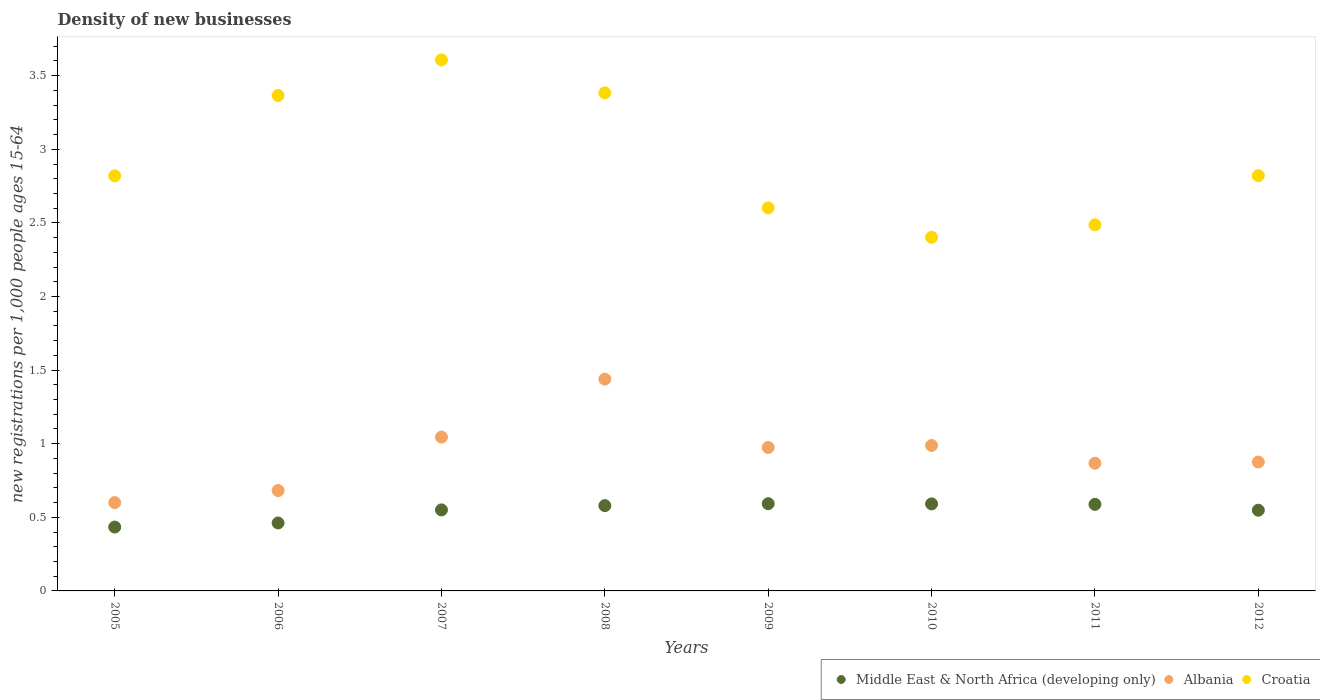What is the number of new registrations in Albania in 2011?
Your response must be concise. 0.87. Across all years, what is the maximum number of new registrations in Middle East & North Africa (developing only)?
Keep it short and to the point. 0.59. Across all years, what is the minimum number of new registrations in Croatia?
Offer a terse response. 2.4. In which year was the number of new registrations in Croatia maximum?
Ensure brevity in your answer.  2007. In which year was the number of new registrations in Croatia minimum?
Offer a terse response. 2010. What is the total number of new registrations in Albania in the graph?
Your response must be concise. 7.47. What is the difference between the number of new registrations in Albania in 2006 and that in 2010?
Provide a succinct answer. -0.31. What is the difference between the number of new registrations in Albania in 2007 and the number of new registrations in Croatia in 2009?
Make the answer very short. -1.56. What is the average number of new registrations in Middle East & North Africa (developing only) per year?
Ensure brevity in your answer.  0.54. In the year 2005, what is the difference between the number of new registrations in Albania and number of new registrations in Croatia?
Make the answer very short. -2.22. What is the ratio of the number of new registrations in Albania in 2008 to that in 2011?
Your answer should be very brief. 1.66. Is the number of new registrations in Croatia in 2009 less than that in 2011?
Ensure brevity in your answer.  No. Is the difference between the number of new registrations in Albania in 2005 and 2012 greater than the difference between the number of new registrations in Croatia in 2005 and 2012?
Keep it short and to the point. No. What is the difference between the highest and the second highest number of new registrations in Albania?
Keep it short and to the point. 0.39. What is the difference between the highest and the lowest number of new registrations in Albania?
Keep it short and to the point. 0.84. In how many years, is the number of new registrations in Albania greater than the average number of new registrations in Albania taken over all years?
Provide a short and direct response. 4. Is the sum of the number of new registrations in Middle East & North Africa (developing only) in 2005 and 2010 greater than the maximum number of new registrations in Albania across all years?
Offer a terse response. No. Does the number of new registrations in Middle East & North Africa (developing only) monotonically increase over the years?
Give a very brief answer. No. Is the number of new registrations in Middle East & North Africa (developing only) strictly greater than the number of new registrations in Albania over the years?
Your answer should be very brief. No. Is the number of new registrations in Croatia strictly less than the number of new registrations in Middle East & North Africa (developing only) over the years?
Keep it short and to the point. No. What is the difference between two consecutive major ticks on the Y-axis?
Your answer should be very brief. 0.5. Does the graph contain grids?
Provide a succinct answer. No. Where does the legend appear in the graph?
Your response must be concise. Bottom right. How many legend labels are there?
Your answer should be compact. 3. What is the title of the graph?
Your answer should be compact. Density of new businesses. What is the label or title of the X-axis?
Ensure brevity in your answer.  Years. What is the label or title of the Y-axis?
Your response must be concise. New registrations per 1,0 people ages 15-64. What is the new registrations per 1,000 people ages 15-64 in Middle East & North Africa (developing only) in 2005?
Provide a short and direct response. 0.43. What is the new registrations per 1,000 people ages 15-64 of Albania in 2005?
Make the answer very short. 0.6. What is the new registrations per 1,000 people ages 15-64 in Croatia in 2005?
Your response must be concise. 2.82. What is the new registrations per 1,000 people ages 15-64 in Middle East & North Africa (developing only) in 2006?
Your response must be concise. 0.46. What is the new registrations per 1,000 people ages 15-64 in Albania in 2006?
Provide a short and direct response. 0.68. What is the new registrations per 1,000 people ages 15-64 of Croatia in 2006?
Make the answer very short. 3.37. What is the new registrations per 1,000 people ages 15-64 of Middle East & North Africa (developing only) in 2007?
Provide a short and direct response. 0.55. What is the new registrations per 1,000 people ages 15-64 of Albania in 2007?
Your response must be concise. 1.04. What is the new registrations per 1,000 people ages 15-64 of Croatia in 2007?
Offer a very short reply. 3.61. What is the new registrations per 1,000 people ages 15-64 of Middle East & North Africa (developing only) in 2008?
Ensure brevity in your answer.  0.58. What is the new registrations per 1,000 people ages 15-64 of Albania in 2008?
Provide a short and direct response. 1.44. What is the new registrations per 1,000 people ages 15-64 in Croatia in 2008?
Offer a terse response. 3.38. What is the new registrations per 1,000 people ages 15-64 of Middle East & North Africa (developing only) in 2009?
Make the answer very short. 0.59. What is the new registrations per 1,000 people ages 15-64 in Albania in 2009?
Provide a short and direct response. 0.97. What is the new registrations per 1,000 people ages 15-64 in Croatia in 2009?
Make the answer very short. 2.6. What is the new registrations per 1,000 people ages 15-64 in Middle East & North Africa (developing only) in 2010?
Give a very brief answer. 0.59. What is the new registrations per 1,000 people ages 15-64 in Albania in 2010?
Your response must be concise. 0.99. What is the new registrations per 1,000 people ages 15-64 in Croatia in 2010?
Offer a very short reply. 2.4. What is the new registrations per 1,000 people ages 15-64 in Middle East & North Africa (developing only) in 2011?
Ensure brevity in your answer.  0.59. What is the new registrations per 1,000 people ages 15-64 in Albania in 2011?
Your answer should be very brief. 0.87. What is the new registrations per 1,000 people ages 15-64 of Croatia in 2011?
Provide a short and direct response. 2.49. What is the new registrations per 1,000 people ages 15-64 in Middle East & North Africa (developing only) in 2012?
Keep it short and to the point. 0.55. What is the new registrations per 1,000 people ages 15-64 in Albania in 2012?
Give a very brief answer. 0.88. What is the new registrations per 1,000 people ages 15-64 of Croatia in 2012?
Offer a terse response. 2.82. Across all years, what is the maximum new registrations per 1,000 people ages 15-64 of Middle East & North Africa (developing only)?
Your answer should be very brief. 0.59. Across all years, what is the maximum new registrations per 1,000 people ages 15-64 in Albania?
Ensure brevity in your answer.  1.44. Across all years, what is the maximum new registrations per 1,000 people ages 15-64 of Croatia?
Provide a succinct answer. 3.61. Across all years, what is the minimum new registrations per 1,000 people ages 15-64 in Middle East & North Africa (developing only)?
Offer a very short reply. 0.43. Across all years, what is the minimum new registrations per 1,000 people ages 15-64 in Albania?
Offer a terse response. 0.6. Across all years, what is the minimum new registrations per 1,000 people ages 15-64 of Croatia?
Your answer should be very brief. 2.4. What is the total new registrations per 1,000 people ages 15-64 of Middle East & North Africa (developing only) in the graph?
Offer a terse response. 4.35. What is the total new registrations per 1,000 people ages 15-64 of Albania in the graph?
Your answer should be compact. 7.47. What is the total new registrations per 1,000 people ages 15-64 of Croatia in the graph?
Your answer should be very brief. 23.49. What is the difference between the new registrations per 1,000 people ages 15-64 of Middle East & North Africa (developing only) in 2005 and that in 2006?
Provide a succinct answer. -0.03. What is the difference between the new registrations per 1,000 people ages 15-64 in Albania in 2005 and that in 2006?
Give a very brief answer. -0.08. What is the difference between the new registrations per 1,000 people ages 15-64 in Croatia in 2005 and that in 2006?
Give a very brief answer. -0.55. What is the difference between the new registrations per 1,000 people ages 15-64 in Middle East & North Africa (developing only) in 2005 and that in 2007?
Ensure brevity in your answer.  -0.12. What is the difference between the new registrations per 1,000 people ages 15-64 of Albania in 2005 and that in 2007?
Give a very brief answer. -0.45. What is the difference between the new registrations per 1,000 people ages 15-64 in Croatia in 2005 and that in 2007?
Provide a succinct answer. -0.79. What is the difference between the new registrations per 1,000 people ages 15-64 in Middle East & North Africa (developing only) in 2005 and that in 2008?
Give a very brief answer. -0.15. What is the difference between the new registrations per 1,000 people ages 15-64 in Albania in 2005 and that in 2008?
Your response must be concise. -0.84. What is the difference between the new registrations per 1,000 people ages 15-64 of Croatia in 2005 and that in 2008?
Your answer should be compact. -0.56. What is the difference between the new registrations per 1,000 people ages 15-64 in Middle East & North Africa (developing only) in 2005 and that in 2009?
Offer a terse response. -0.16. What is the difference between the new registrations per 1,000 people ages 15-64 in Albania in 2005 and that in 2009?
Keep it short and to the point. -0.37. What is the difference between the new registrations per 1,000 people ages 15-64 in Croatia in 2005 and that in 2009?
Your answer should be very brief. 0.22. What is the difference between the new registrations per 1,000 people ages 15-64 of Middle East & North Africa (developing only) in 2005 and that in 2010?
Offer a terse response. -0.16. What is the difference between the new registrations per 1,000 people ages 15-64 of Albania in 2005 and that in 2010?
Offer a terse response. -0.39. What is the difference between the new registrations per 1,000 people ages 15-64 of Croatia in 2005 and that in 2010?
Ensure brevity in your answer.  0.42. What is the difference between the new registrations per 1,000 people ages 15-64 of Middle East & North Africa (developing only) in 2005 and that in 2011?
Provide a succinct answer. -0.15. What is the difference between the new registrations per 1,000 people ages 15-64 of Albania in 2005 and that in 2011?
Your answer should be compact. -0.27. What is the difference between the new registrations per 1,000 people ages 15-64 in Croatia in 2005 and that in 2011?
Provide a short and direct response. 0.33. What is the difference between the new registrations per 1,000 people ages 15-64 in Middle East & North Africa (developing only) in 2005 and that in 2012?
Your response must be concise. -0.11. What is the difference between the new registrations per 1,000 people ages 15-64 in Albania in 2005 and that in 2012?
Your response must be concise. -0.28. What is the difference between the new registrations per 1,000 people ages 15-64 in Croatia in 2005 and that in 2012?
Your answer should be compact. -0. What is the difference between the new registrations per 1,000 people ages 15-64 in Middle East & North Africa (developing only) in 2006 and that in 2007?
Ensure brevity in your answer.  -0.09. What is the difference between the new registrations per 1,000 people ages 15-64 of Albania in 2006 and that in 2007?
Make the answer very short. -0.36. What is the difference between the new registrations per 1,000 people ages 15-64 of Croatia in 2006 and that in 2007?
Your response must be concise. -0.24. What is the difference between the new registrations per 1,000 people ages 15-64 in Middle East & North Africa (developing only) in 2006 and that in 2008?
Ensure brevity in your answer.  -0.12. What is the difference between the new registrations per 1,000 people ages 15-64 of Albania in 2006 and that in 2008?
Ensure brevity in your answer.  -0.76. What is the difference between the new registrations per 1,000 people ages 15-64 of Croatia in 2006 and that in 2008?
Offer a very short reply. -0.02. What is the difference between the new registrations per 1,000 people ages 15-64 of Middle East & North Africa (developing only) in 2006 and that in 2009?
Provide a succinct answer. -0.13. What is the difference between the new registrations per 1,000 people ages 15-64 of Albania in 2006 and that in 2009?
Make the answer very short. -0.29. What is the difference between the new registrations per 1,000 people ages 15-64 in Croatia in 2006 and that in 2009?
Offer a very short reply. 0.76. What is the difference between the new registrations per 1,000 people ages 15-64 in Middle East & North Africa (developing only) in 2006 and that in 2010?
Offer a very short reply. -0.13. What is the difference between the new registrations per 1,000 people ages 15-64 in Albania in 2006 and that in 2010?
Your response must be concise. -0.31. What is the difference between the new registrations per 1,000 people ages 15-64 of Croatia in 2006 and that in 2010?
Your answer should be very brief. 0.96. What is the difference between the new registrations per 1,000 people ages 15-64 in Middle East & North Africa (developing only) in 2006 and that in 2011?
Your answer should be very brief. -0.13. What is the difference between the new registrations per 1,000 people ages 15-64 in Albania in 2006 and that in 2011?
Offer a very short reply. -0.19. What is the difference between the new registrations per 1,000 people ages 15-64 in Croatia in 2006 and that in 2011?
Your answer should be compact. 0.88. What is the difference between the new registrations per 1,000 people ages 15-64 of Middle East & North Africa (developing only) in 2006 and that in 2012?
Keep it short and to the point. -0.09. What is the difference between the new registrations per 1,000 people ages 15-64 in Albania in 2006 and that in 2012?
Offer a terse response. -0.19. What is the difference between the new registrations per 1,000 people ages 15-64 of Croatia in 2006 and that in 2012?
Keep it short and to the point. 0.54. What is the difference between the new registrations per 1,000 people ages 15-64 of Middle East & North Africa (developing only) in 2007 and that in 2008?
Your response must be concise. -0.03. What is the difference between the new registrations per 1,000 people ages 15-64 of Albania in 2007 and that in 2008?
Ensure brevity in your answer.  -0.39. What is the difference between the new registrations per 1,000 people ages 15-64 of Croatia in 2007 and that in 2008?
Your answer should be very brief. 0.22. What is the difference between the new registrations per 1,000 people ages 15-64 in Middle East & North Africa (developing only) in 2007 and that in 2009?
Ensure brevity in your answer.  -0.04. What is the difference between the new registrations per 1,000 people ages 15-64 in Albania in 2007 and that in 2009?
Your answer should be compact. 0.07. What is the difference between the new registrations per 1,000 people ages 15-64 of Croatia in 2007 and that in 2009?
Your response must be concise. 1. What is the difference between the new registrations per 1,000 people ages 15-64 in Middle East & North Africa (developing only) in 2007 and that in 2010?
Give a very brief answer. -0.04. What is the difference between the new registrations per 1,000 people ages 15-64 of Albania in 2007 and that in 2010?
Provide a short and direct response. 0.06. What is the difference between the new registrations per 1,000 people ages 15-64 in Croatia in 2007 and that in 2010?
Offer a terse response. 1.2. What is the difference between the new registrations per 1,000 people ages 15-64 of Middle East & North Africa (developing only) in 2007 and that in 2011?
Ensure brevity in your answer.  -0.04. What is the difference between the new registrations per 1,000 people ages 15-64 in Albania in 2007 and that in 2011?
Your answer should be very brief. 0.18. What is the difference between the new registrations per 1,000 people ages 15-64 in Croatia in 2007 and that in 2011?
Provide a succinct answer. 1.12. What is the difference between the new registrations per 1,000 people ages 15-64 of Middle East & North Africa (developing only) in 2007 and that in 2012?
Your answer should be compact. 0. What is the difference between the new registrations per 1,000 people ages 15-64 in Albania in 2007 and that in 2012?
Your answer should be very brief. 0.17. What is the difference between the new registrations per 1,000 people ages 15-64 of Croatia in 2007 and that in 2012?
Provide a succinct answer. 0.79. What is the difference between the new registrations per 1,000 people ages 15-64 of Middle East & North Africa (developing only) in 2008 and that in 2009?
Your answer should be very brief. -0.01. What is the difference between the new registrations per 1,000 people ages 15-64 of Albania in 2008 and that in 2009?
Offer a very short reply. 0.46. What is the difference between the new registrations per 1,000 people ages 15-64 of Croatia in 2008 and that in 2009?
Offer a terse response. 0.78. What is the difference between the new registrations per 1,000 people ages 15-64 of Middle East & North Africa (developing only) in 2008 and that in 2010?
Ensure brevity in your answer.  -0.01. What is the difference between the new registrations per 1,000 people ages 15-64 in Albania in 2008 and that in 2010?
Offer a very short reply. 0.45. What is the difference between the new registrations per 1,000 people ages 15-64 in Middle East & North Africa (developing only) in 2008 and that in 2011?
Your answer should be compact. -0.01. What is the difference between the new registrations per 1,000 people ages 15-64 of Albania in 2008 and that in 2011?
Provide a succinct answer. 0.57. What is the difference between the new registrations per 1,000 people ages 15-64 in Croatia in 2008 and that in 2011?
Your answer should be compact. 0.9. What is the difference between the new registrations per 1,000 people ages 15-64 in Middle East & North Africa (developing only) in 2008 and that in 2012?
Your answer should be compact. 0.03. What is the difference between the new registrations per 1,000 people ages 15-64 in Albania in 2008 and that in 2012?
Give a very brief answer. 0.56. What is the difference between the new registrations per 1,000 people ages 15-64 of Croatia in 2008 and that in 2012?
Give a very brief answer. 0.56. What is the difference between the new registrations per 1,000 people ages 15-64 of Middle East & North Africa (developing only) in 2009 and that in 2010?
Offer a terse response. 0. What is the difference between the new registrations per 1,000 people ages 15-64 in Albania in 2009 and that in 2010?
Keep it short and to the point. -0.01. What is the difference between the new registrations per 1,000 people ages 15-64 in Croatia in 2009 and that in 2010?
Offer a terse response. 0.2. What is the difference between the new registrations per 1,000 people ages 15-64 in Middle East & North Africa (developing only) in 2009 and that in 2011?
Give a very brief answer. 0. What is the difference between the new registrations per 1,000 people ages 15-64 of Albania in 2009 and that in 2011?
Offer a terse response. 0.11. What is the difference between the new registrations per 1,000 people ages 15-64 in Croatia in 2009 and that in 2011?
Your answer should be very brief. 0.12. What is the difference between the new registrations per 1,000 people ages 15-64 of Middle East & North Africa (developing only) in 2009 and that in 2012?
Provide a succinct answer. 0.04. What is the difference between the new registrations per 1,000 people ages 15-64 of Albania in 2009 and that in 2012?
Your answer should be compact. 0.1. What is the difference between the new registrations per 1,000 people ages 15-64 in Croatia in 2009 and that in 2012?
Keep it short and to the point. -0.22. What is the difference between the new registrations per 1,000 people ages 15-64 in Middle East & North Africa (developing only) in 2010 and that in 2011?
Provide a succinct answer. 0. What is the difference between the new registrations per 1,000 people ages 15-64 in Albania in 2010 and that in 2011?
Give a very brief answer. 0.12. What is the difference between the new registrations per 1,000 people ages 15-64 of Croatia in 2010 and that in 2011?
Your answer should be compact. -0.08. What is the difference between the new registrations per 1,000 people ages 15-64 of Middle East & North Africa (developing only) in 2010 and that in 2012?
Give a very brief answer. 0.04. What is the difference between the new registrations per 1,000 people ages 15-64 in Albania in 2010 and that in 2012?
Offer a very short reply. 0.11. What is the difference between the new registrations per 1,000 people ages 15-64 in Croatia in 2010 and that in 2012?
Keep it short and to the point. -0.42. What is the difference between the new registrations per 1,000 people ages 15-64 in Middle East & North Africa (developing only) in 2011 and that in 2012?
Your answer should be compact. 0.04. What is the difference between the new registrations per 1,000 people ages 15-64 of Albania in 2011 and that in 2012?
Make the answer very short. -0.01. What is the difference between the new registrations per 1,000 people ages 15-64 in Croatia in 2011 and that in 2012?
Offer a very short reply. -0.33. What is the difference between the new registrations per 1,000 people ages 15-64 in Middle East & North Africa (developing only) in 2005 and the new registrations per 1,000 people ages 15-64 in Albania in 2006?
Offer a very short reply. -0.25. What is the difference between the new registrations per 1,000 people ages 15-64 of Middle East & North Africa (developing only) in 2005 and the new registrations per 1,000 people ages 15-64 of Croatia in 2006?
Your answer should be very brief. -2.93. What is the difference between the new registrations per 1,000 people ages 15-64 of Albania in 2005 and the new registrations per 1,000 people ages 15-64 of Croatia in 2006?
Your answer should be very brief. -2.77. What is the difference between the new registrations per 1,000 people ages 15-64 of Middle East & North Africa (developing only) in 2005 and the new registrations per 1,000 people ages 15-64 of Albania in 2007?
Provide a succinct answer. -0.61. What is the difference between the new registrations per 1,000 people ages 15-64 of Middle East & North Africa (developing only) in 2005 and the new registrations per 1,000 people ages 15-64 of Croatia in 2007?
Your response must be concise. -3.17. What is the difference between the new registrations per 1,000 people ages 15-64 in Albania in 2005 and the new registrations per 1,000 people ages 15-64 in Croatia in 2007?
Your answer should be compact. -3.01. What is the difference between the new registrations per 1,000 people ages 15-64 in Middle East & North Africa (developing only) in 2005 and the new registrations per 1,000 people ages 15-64 in Albania in 2008?
Make the answer very short. -1. What is the difference between the new registrations per 1,000 people ages 15-64 in Middle East & North Africa (developing only) in 2005 and the new registrations per 1,000 people ages 15-64 in Croatia in 2008?
Offer a terse response. -2.95. What is the difference between the new registrations per 1,000 people ages 15-64 of Albania in 2005 and the new registrations per 1,000 people ages 15-64 of Croatia in 2008?
Give a very brief answer. -2.78. What is the difference between the new registrations per 1,000 people ages 15-64 in Middle East & North Africa (developing only) in 2005 and the new registrations per 1,000 people ages 15-64 in Albania in 2009?
Make the answer very short. -0.54. What is the difference between the new registrations per 1,000 people ages 15-64 in Middle East & North Africa (developing only) in 2005 and the new registrations per 1,000 people ages 15-64 in Croatia in 2009?
Offer a very short reply. -2.17. What is the difference between the new registrations per 1,000 people ages 15-64 in Albania in 2005 and the new registrations per 1,000 people ages 15-64 in Croatia in 2009?
Give a very brief answer. -2. What is the difference between the new registrations per 1,000 people ages 15-64 of Middle East & North Africa (developing only) in 2005 and the new registrations per 1,000 people ages 15-64 of Albania in 2010?
Keep it short and to the point. -0.55. What is the difference between the new registrations per 1,000 people ages 15-64 in Middle East & North Africa (developing only) in 2005 and the new registrations per 1,000 people ages 15-64 in Croatia in 2010?
Give a very brief answer. -1.97. What is the difference between the new registrations per 1,000 people ages 15-64 of Albania in 2005 and the new registrations per 1,000 people ages 15-64 of Croatia in 2010?
Keep it short and to the point. -1.8. What is the difference between the new registrations per 1,000 people ages 15-64 in Middle East & North Africa (developing only) in 2005 and the new registrations per 1,000 people ages 15-64 in Albania in 2011?
Your answer should be compact. -0.43. What is the difference between the new registrations per 1,000 people ages 15-64 in Middle East & North Africa (developing only) in 2005 and the new registrations per 1,000 people ages 15-64 in Croatia in 2011?
Provide a short and direct response. -2.05. What is the difference between the new registrations per 1,000 people ages 15-64 in Albania in 2005 and the new registrations per 1,000 people ages 15-64 in Croatia in 2011?
Keep it short and to the point. -1.89. What is the difference between the new registrations per 1,000 people ages 15-64 of Middle East & North Africa (developing only) in 2005 and the new registrations per 1,000 people ages 15-64 of Albania in 2012?
Your response must be concise. -0.44. What is the difference between the new registrations per 1,000 people ages 15-64 of Middle East & North Africa (developing only) in 2005 and the new registrations per 1,000 people ages 15-64 of Croatia in 2012?
Your response must be concise. -2.39. What is the difference between the new registrations per 1,000 people ages 15-64 in Albania in 2005 and the new registrations per 1,000 people ages 15-64 in Croatia in 2012?
Offer a very short reply. -2.22. What is the difference between the new registrations per 1,000 people ages 15-64 of Middle East & North Africa (developing only) in 2006 and the new registrations per 1,000 people ages 15-64 of Albania in 2007?
Your answer should be compact. -0.58. What is the difference between the new registrations per 1,000 people ages 15-64 in Middle East & North Africa (developing only) in 2006 and the new registrations per 1,000 people ages 15-64 in Croatia in 2007?
Make the answer very short. -3.15. What is the difference between the new registrations per 1,000 people ages 15-64 of Albania in 2006 and the new registrations per 1,000 people ages 15-64 of Croatia in 2007?
Ensure brevity in your answer.  -2.93. What is the difference between the new registrations per 1,000 people ages 15-64 of Middle East & North Africa (developing only) in 2006 and the new registrations per 1,000 people ages 15-64 of Albania in 2008?
Make the answer very short. -0.98. What is the difference between the new registrations per 1,000 people ages 15-64 of Middle East & North Africa (developing only) in 2006 and the new registrations per 1,000 people ages 15-64 of Croatia in 2008?
Offer a very short reply. -2.92. What is the difference between the new registrations per 1,000 people ages 15-64 in Albania in 2006 and the new registrations per 1,000 people ages 15-64 in Croatia in 2008?
Make the answer very short. -2.7. What is the difference between the new registrations per 1,000 people ages 15-64 of Middle East & North Africa (developing only) in 2006 and the new registrations per 1,000 people ages 15-64 of Albania in 2009?
Keep it short and to the point. -0.51. What is the difference between the new registrations per 1,000 people ages 15-64 in Middle East & North Africa (developing only) in 2006 and the new registrations per 1,000 people ages 15-64 in Croatia in 2009?
Offer a very short reply. -2.14. What is the difference between the new registrations per 1,000 people ages 15-64 in Albania in 2006 and the new registrations per 1,000 people ages 15-64 in Croatia in 2009?
Provide a short and direct response. -1.92. What is the difference between the new registrations per 1,000 people ages 15-64 of Middle East & North Africa (developing only) in 2006 and the new registrations per 1,000 people ages 15-64 of Albania in 2010?
Ensure brevity in your answer.  -0.53. What is the difference between the new registrations per 1,000 people ages 15-64 of Middle East & North Africa (developing only) in 2006 and the new registrations per 1,000 people ages 15-64 of Croatia in 2010?
Offer a very short reply. -1.94. What is the difference between the new registrations per 1,000 people ages 15-64 in Albania in 2006 and the new registrations per 1,000 people ages 15-64 in Croatia in 2010?
Provide a short and direct response. -1.72. What is the difference between the new registrations per 1,000 people ages 15-64 of Middle East & North Africa (developing only) in 2006 and the new registrations per 1,000 people ages 15-64 of Albania in 2011?
Provide a succinct answer. -0.41. What is the difference between the new registrations per 1,000 people ages 15-64 in Middle East & North Africa (developing only) in 2006 and the new registrations per 1,000 people ages 15-64 in Croatia in 2011?
Your answer should be very brief. -2.03. What is the difference between the new registrations per 1,000 people ages 15-64 in Albania in 2006 and the new registrations per 1,000 people ages 15-64 in Croatia in 2011?
Give a very brief answer. -1.81. What is the difference between the new registrations per 1,000 people ages 15-64 of Middle East & North Africa (developing only) in 2006 and the new registrations per 1,000 people ages 15-64 of Albania in 2012?
Keep it short and to the point. -0.41. What is the difference between the new registrations per 1,000 people ages 15-64 of Middle East & North Africa (developing only) in 2006 and the new registrations per 1,000 people ages 15-64 of Croatia in 2012?
Make the answer very short. -2.36. What is the difference between the new registrations per 1,000 people ages 15-64 in Albania in 2006 and the new registrations per 1,000 people ages 15-64 in Croatia in 2012?
Offer a terse response. -2.14. What is the difference between the new registrations per 1,000 people ages 15-64 in Middle East & North Africa (developing only) in 2007 and the new registrations per 1,000 people ages 15-64 in Albania in 2008?
Your response must be concise. -0.89. What is the difference between the new registrations per 1,000 people ages 15-64 of Middle East & North Africa (developing only) in 2007 and the new registrations per 1,000 people ages 15-64 of Croatia in 2008?
Your answer should be very brief. -2.83. What is the difference between the new registrations per 1,000 people ages 15-64 of Albania in 2007 and the new registrations per 1,000 people ages 15-64 of Croatia in 2008?
Provide a succinct answer. -2.34. What is the difference between the new registrations per 1,000 people ages 15-64 in Middle East & North Africa (developing only) in 2007 and the new registrations per 1,000 people ages 15-64 in Albania in 2009?
Make the answer very short. -0.42. What is the difference between the new registrations per 1,000 people ages 15-64 of Middle East & North Africa (developing only) in 2007 and the new registrations per 1,000 people ages 15-64 of Croatia in 2009?
Make the answer very short. -2.05. What is the difference between the new registrations per 1,000 people ages 15-64 of Albania in 2007 and the new registrations per 1,000 people ages 15-64 of Croatia in 2009?
Give a very brief answer. -1.56. What is the difference between the new registrations per 1,000 people ages 15-64 of Middle East & North Africa (developing only) in 2007 and the new registrations per 1,000 people ages 15-64 of Albania in 2010?
Ensure brevity in your answer.  -0.44. What is the difference between the new registrations per 1,000 people ages 15-64 in Middle East & North Africa (developing only) in 2007 and the new registrations per 1,000 people ages 15-64 in Croatia in 2010?
Offer a very short reply. -1.85. What is the difference between the new registrations per 1,000 people ages 15-64 of Albania in 2007 and the new registrations per 1,000 people ages 15-64 of Croatia in 2010?
Your response must be concise. -1.36. What is the difference between the new registrations per 1,000 people ages 15-64 of Middle East & North Africa (developing only) in 2007 and the new registrations per 1,000 people ages 15-64 of Albania in 2011?
Offer a terse response. -0.32. What is the difference between the new registrations per 1,000 people ages 15-64 in Middle East & North Africa (developing only) in 2007 and the new registrations per 1,000 people ages 15-64 in Croatia in 2011?
Keep it short and to the point. -1.94. What is the difference between the new registrations per 1,000 people ages 15-64 in Albania in 2007 and the new registrations per 1,000 people ages 15-64 in Croatia in 2011?
Keep it short and to the point. -1.44. What is the difference between the new registrations per 1,000 people ages 15-64 in Middle East & North Africa (developing only) in 2007 and the new registrations per 1,000 people ages 15-64 in Albania in 2012?
Your answer should be very brief. -0.33. What is the difference between the new registrations per 1,000 people ages 15-64 of Middle East & North Africa (developing only) in 2007 and the new registrations per 1,000 people ages 15-64 of Croatia in 2012?
Your answer should be very brief. -2.27. What is the difference between the new registrations per 1,000 people ages 15-64 in Albania in 2007 and the new registrations per 1,000 people ages 15-64 in Croatia in 2012?
Offer a terse response. -1.78. What is the difference between the new registrations per 1,000 people ages 15-64 in Middle East & North Africa (developing only) in 2008 and the new registrations per 1,000 people ages 15-64 in Albania in 2009?
Offer a very short reply. -0.4. What is the difference between the new registrations per 1,000 people ages 15-64 in Middle East & North Africa (developing only) in 2008 and the new registrations per 1,000 people ages 15-64 in Croatia in 2009?
Make the answer very short. -2.02. What is the difference between the new registrations per 1,000 people ages 15-64 in Albania in 2008 and the new registrations per 1,000 people ages 15-64 in Croatia in 2009?
Provide a succinct answer. -1.16. What is the difference between the new registrations per 1,000 people ages 15-64 in Middle East & North Africa (developing only) in 2008 and the new registrations per 1,000 people ages 15-64 in Albania in 2010?
Offer a terse response. -0.41. What is the difference between the new registrations per 1,000 people ages 15-64 in Middle East & North Africa (developing only) in 2008 and the new registrations per 1,000 people ages 15-64 in Croatia in 2010?
Give a very brief answer. -1.82. What is the difference between the new registrations per 1,000 people ages 15-64 of Albania in 2008 and the new registrations per 1,000 people ages 15-64 of Croatia in 2010?
Offer a terse response. -0.96. What is the difference between the new registrations per 1,000 people ages 15-64 of Middle East & North Africa (developing only) in 2008 and the new registrations per 1,000 people ages 15-64 of Albania in 2011?
Your response must be concise. -0.29. What is the difference between the new registrations per 1,000 people ages 15-64 in Middle East & North Africa (developing only) in 2008 and the new registrations per 1,000 people ages 15-64 in Croatia in 2011?
Your answer should be compact. -1.91. What is the difference between the new registrations per 1,000 people ages 15-64 of Albania in 2008 and the new registrations per 1,000 people ages 15-64 of Croatia in 2011?
Give a very brief answer. -1.05. What is the difference between the new registrations per 1,000 people ages 15-64 in Middle East & North Africa (developing only) in 2008 and the new registrations per 1,000 people ages 15-64 in Albania in 2012?
Your answer should be very brief. -0.3. What is the difference between the new registrations per 1,000 people ages 15-64 of Middle East & North Africa (developing only) in 2008 and the new registrations per 1,000 people ages 15-64 of Croatia in 2012?
Make the answer very short. -2.24. What is the difference between the new registrations per 1,000 people ages 15-64 in Albania in 2008 and the new registrations per 1,000 people ages 15-64 in Croatia in 2012?
Your response must be concise. -1.38. What is the difference between the new registrations per 1,000 people ages 15-64 in Middle East & North Africa (developing only) in 2009 and the new registrations per 1,000 people ages 15-64 in Albania in 2010?
Provide a succinct answer. -0.4. What is the difference between the new registrations per 1,000 people ages 15-64 in Middle East & North Africa (developing only) in 2009 and the new registrations per 1,000 people ages 15-64 in Croatia in 2010?
Your answer should be very brief. -1.81. What is the difference between the new registrations per 1,000 people ages 15-64 in Albania in 2009 and the new registrations per 1,000 people ages 15-64 in Croatia in 2010?
Keep it short and to the point. -1.43. What is the difference between the new registrations per 1,000 people ages 15-64 of Middle East & North Africa (developing only) in 2009 and the new registrations per 1,000 people ages 15-64 of Albania in 2011?
Provide a succinct answer. -0.28. What is the difference between the new registrations per 1,000 people ages 15-64 in Middle East & North Africa (developing only) in 2009 and the new registrations per 1,000 people ages 15-64 in Croatia in 2011?
Offer a terse response. -1.89. What is the difference between the new registrations per 1,000 people ages 15-64 in Albania in 2009 and the new registrations per 1,000 people ages 15-64 in Croatia in 2011?
Ensure brevity in your answer.  -1.51. What is the difference between the new registrations per 1,000 people ages 15-64 of Middle East & North Africa (developing only) in 2009 and the new registrations per 1,000 people ages 15-64 of Albania in 2012?
Your answer should be compact. -0.28. What is the difference between the new registrations per 1,000 people ages 15-64 of Middle East & North Africa (developing only) in 2009 and the new registrations per 1,000 people ages 15-64 of Croatia in 2012?
Ensure brevity in your answer.  -2.23. What is the difference between the new registrations per 1,000 people ages 15-64 of Albania in 2009 and the new registrations per 1,000 people ages 15-64 of Croatia in 2012?
Your response must be concise. -1.85. What is the difference between the new registrations per 1,000 people ages 15-64 in Middle East & North Africa (developing only) in 2010 and the new registrations per 1,000 people ages 15-64 in Albania in 2011?
Provide a short and direct response. -0.28. What is the difference between the new registrations per 1,000 people ages 15-64 of Middle East & North Africa (developing only) in 2010 and the new registrations per 1,000 people ages 15-64 of Croatia in 2011?
Offer a terse response. -1.9. What is the difference between the new registrations per 1,000 people ages 15-64 in Albania in 2010 and the new registrations per 1,000 people ages 15-64 in Croatia in 2011?
Keep it short and to the point. -1.5. What is the difference between the new registrations per 1,000 people ages 15-64 of Middle East & North Africa (developing only) in 2010 and the new registrations per 1,000 people ages 15-64 of Albania in 2012?
Make the answer very short. -0.28. What is the difference between the new registrations per 1,000 people ages 15-64 in Middle East & North Africa (developing only) in 2010 and the new registrations per 1,000 people ages 15-64 in Croatia in 2012?
Provide a succinct answer. -2.23. What is the difference between the new registrations per 1,000 people ages 15-64 in Albania in 2010 and the new registrations per 1,000 people ages 15-64 in Croatia in 2012?
Provide a succinct answer. -1.83. What is the difference between the new registrations per 1,000 people ages 15-64 in Middle East & North Africa (developing only) in 2011 and the new registrations per 1,000 people ages 15-64 in Albania in 2012?
Ensure brevity in your answer.  -0.29. What is the difference between the new registrations per 1,000 people ages 15-64 in Middle East & North Africa (developing only) in 2011 and the new registrations per 1,000 people ages 15-64 in Croatia in 2012?
Your answer should be compact. -2.23. What is the difference between the new registrations per 1,000 people ages 15-64 in Albania in 2011 and the new registrations per 1,000 people ages 15-64 in Croatia in 2012?
Keep it short and to the point. -1.95. What is the average new registrations per 1,000 people ages 15-64 of Middle East & North Africa (developing only) per year?
Offer a very short reply. 0.54. What is the average new registrations per 1,000 people ages 15-64 of Albania per year?
Ensure brevity in your answer.  0.93. What is the average new registrations per 1,000 people ages 15-64 in Croatia per year?
Ensure brevity in your answer.  2.94. In the year 2005, what is the difference between the new registrations per 1,000 people ages 15-64 in Middle East & North Africa (developing only) and new registrations per 1,000 people ages 15-64 in Albania?
Provide a short and direct response. -0.17. In the year 2005, what is the difference between the new registrations per 1,000 people ages 15-64 of Middle East & North Africa (developing only) and new registrations per 1,000 people ages 15-64 of Croatia?
Keep it short and to the point. -2.39. In the year 2005, what is the difference between the new registrations per 1,000 people ages 15-64 in Albania and new registrations per 1,000 people ages 15-64 in Croatia?
Make the answer very short. -2.22. In the year 2006, what is the difference between the new registrations per 1,000 people ages 15-64 in Middle East & North Africa (developing only) and new registrations per 1,000 people ages 15-64 in Albania?
Offer a terse response. -0.22. In the year 2006, what is the difference between the new registrations per 1,000 people ages 15-64 in Middle East & North Africa (developing only) and new registrations per 1,000 people ages 15-64 in Croatia?
Offer a very short reply. -2.9. In the year 2006, what is the difference between the new registrations per 1,000 people ages 15-64 in Albania and new registrations per 1,000 people ages 15-64 in Croatia?
Offer a very short reply. -2.68. In the year 2007, what is the difference between the new registrations per 1,000 people ages 15-64 of Middle East & North Africa (developing only) and new registrations per 1,000 people ages 15-64 of Albania?
Keep it short and to the point. -0.49. In the year 2007, what is the difference between the new registrations per 1,000 people ages 15-64 of Middle East & North Africa (developing only) and new registrations per 1,000 people ages 15-64 of Croatia?
Give a very brief answer. -3.06. In the year 2007, what is the difference between the new registrations per 1,000 people ages 15-64 of Albania and new registrations per 1,000 people ages 15-64 of Croatia?
Provide a short and direct response. -2.56. In the year 2008, what is the difference between the new registrations per 1,000 people ages 15-64 in Middle East & North Africa (developing only) and new registrations per 1,000 people ages 15-64 in Albania?
Provide a succinct answer. -0.86. In the year 2008, what is the difference between the new registrations per 1,000 people ages 15-64 of Middle East & North Africa (developing only) and new registrations per 1,000 people ages 15-64 of Croatia?
Make the answer very short. -2.8. In the year 2008, what is the difference between the new registrations per 1,000 people ages 15-64 in Albania and new registrations per 1,000 people ages 15-64 in Croatia?
Make the answer very short. -1.94. In the year 2009, what is the difference between the new registrations per 1,000 people ages 15-64 in Middle East & North Africa (developing only) and new registrations per 1,000 people ages 15-64 in Albania?
Ensure brevity in your answer.  -0.38. In the year 2009, what is the difference between the new registrations per 1,000 people ages 15-64 of Middle East & North Africa (developing only) and new registrations per 1,000 people ages 15-64 of Croatia?
Make the answer very short. -2.01. In the year 2009, what is the difference between the new registrations per 1,000 people ages 15-64 of Albania and new registrations per 1,000 people ages 15-64 of Croatia?
Your answer should be compact. -1.63. In the year 2010, what is the difference between the new registrations per 1,000 people ages 15-64 of Middle East & North Africa (developing only) and new registrations per 1,000 people ages 15-64 of Albania?
Offer a terse response. -0.4. In the year 2010, what is the difference between the new registrations per 1,000 people ages 15-64 in Middle East & North Africa (developing only) and new registrations per 1,000 people ages 15-64 in Croatia?
Your answer should be compact. -1.81. In the year 2010, what is the difference between the new registrations per 1,000 people ages 15-64 in Albania and new registrations per 1,000 people ages 15-64 in Croatia?
Keep it short and to the point. -1.41. In the year 2011, what is the difference between the new registrations per 1,000 people ages 15-64 of Middle East & North Africa (developing only) and new registrations per 1,000 people ages 15-64 of Albania?
Your answer should be very brief. -0.28. In the year 2011, what is the difference between the new registrations per 1,000 people ages 15-64 of Middle East & North Africa (developing only) and new registrations per 1,000 people ages 15-64 of Croatia?
Offer a terse response. -1.9. In the year 2011, what is the difference between the new registrations per 1,000 people ages 15-64 of Albania and new registrations per 1,000 people ages 15-64 of Croatia?
Provide a short and direct response. -1.62. In the year 2012, what is the difference between the new registrations per 1,000 people ages 15-64 in Middle East & North Africa (developing only) and new registrations per 1,000 people ages 15-64 in Albania?
Your answer should be very brief. -0.33. In the year 2012, what is the difference between the new registrations per 1,000 people ages 15-64 in Middle East & North Africa (developing only) and new registrations per 1,000 people ages 15-64 in Croatia?
Keep it short and to the point. -2.27. In the year 2012, what is the difference between the new registrations per 1,000 people ages 15-64 of Albania and new registrations per 1,000 people ages 15-64 of Croatia?
Ensure brevity in your answer.  -1.95. What is the ratio of the new registrations per 1,000 people ages 15-64 of Middle East & North Africa (developing only) in 2005 to that in 2006?
Give a very brief answer. 0.94. What is the ratio of the new registrations per 1,000 people ages 15-64 in Albania in 2005 to that in 2006?
Ensure brevity in your answer.  0.88. What is the ratio of the new registrations per 1,000 people ages 15-64 of Croatia in 2005 to that in 2006?
Keep it short and to the point. 0.84. What is the ratio of the new registrations per 1,000 people ages 15-64 in Middle East & North Africa (developing only) in 2005 to that in 2007?
Your answer should be very brief. 0.79. What is the ratio of the new registrations per 1,000 people ages 15-64 of Albania in 2005 to that in 2007?
Make the answer very short. 0.57. What is the ratio of the new registrations per 1,000 people ages 15-64 in Croatia in 2005 to that in 2007?
Ensure brevity in your answer.  0.78. What is the ratio of the new registrations per 1,000 people ages 15-64 in Middle East & North Africa (developing only) in 2005 to that in 2008?
Make the answer very short. 0.75. What is the ratio of the new registrations per 1,000 people ages 15-64 of Albania in 2005 to that in 2008?
Provide a succinct answer. 0.42. What is the ratio of the new registrations per 1,000 people ages 15-64 in Croatia in 2005 to that in 2008?
Your answer should be compact. 0.83. What is the ratio of the new registrations per 1,000 people ages 15-64 of Middle East & North Africa (developing only) in 2005 to that in 2009?
Your answer should be very brief. 0.73. What is the ratio of the new registrations per 1,000 people ages 15-64 of Albania in 2005 to that in 2009?
Provide a succinct answer. 0.62. What is the ratio of the new registrations per 1,000 people ages 15-64 of Croatia in 2005 to that in 2009?
Make the answer very short. 1.08. What is the ratio of the new registrations per 1,000 people ages 15-64 of Middle East & North Africa (developing only) in 2005 to that in 2010?
Offer a very short reply. 0.73. What is the ratio of the new registrations per 1,000 people ages 15-64 of Albania in 2005 to that in 2010?
Offer a very short reply. 0.61. What is the ratio of the new registrations per 1,000 people ages 15-64 of Croatia in 2005 to that in 2010?
Provide a succinct answer. 1.17. What is the ratio of the new registrations per 1,000 people ages 15-64 in Middle East & North Africa (developing only) in 2005 to that in 2011?
Offer a terse response. 0.74. What is the ratio of the new registrations per 1,000 people ages 15-64 of Albania in 2005 to that in 2011?
Your response must be concise. 0.69. What is the ratio of the new registrations per 1,000 people ages 15-64 of Croatia in 2005 to that in 2011?
Give a very brief answer. 1.13. What is the ratio of the new registrations per 1,000 people ages 15-64 in Middle East & North Africa (developing only) in 2005 to that in 2012?
Your answer should be compact. 0.79. What is the ratio of the new registrations per 1,000 people ages 15-64 in Albania in 2005 to that in 2012?
Your answer should be compact. 0.69. What is the ratio of the new registrations per 1,000 people ages 15-64 in Croatia in 2005 to that in 2012?
Provide a short and direct response. 1. What is the ratio of the new registrations per 1,000 people ages 15-64 in Middle East & North Africa (developing only) in 2006 to that in 2007?
Ensure brevity in your answer.  0.84. What is the ratio of the new registrations per 1,000 people ages 15-64 of Albania in 2006 to that in 2007?
Give a very brief answer. 0.65. What is the ratio of the new registrations per 1,000 people ages 15-64 of Croatia in 2006 to that in 2007?
Ensure brevity in your answer.  0.93. What is the ratio of the new registrations per 1,000 people ages 15-64 in Middle East & North Africa (developing only) in 2006 to that in 2008?
Your response must be concise. 0.8. What is the ratio of the new registrations per 1,000 people ages 15-64 of Albania in 2006 to that in 2008?
Make the answer very short. 0.47. What is the ratio of the new registrations per 1,000 people ages 15-64 in Croatia in 2006 to that in 2008?
Make the answer very short. 0.99. What is the ratio of the new registrations per 1,000 people ages 15-64 of Middle East & North Africa (developing only) in 2006 to that in 2009?
Your answer should be compact. 0.78. What is the ratio of the new registrations per 1,000 people ages 15-64 in Albania in 2006 to that in 2009?
Offer a very short reply. 0.7. What is the ratio of the new registrations per 1,000 people ages 15-64 of Croatia in 2006 to that in 2009?
Ensure brevity in your answer.  1.29. What is the ratio of the new registrations per 1,000 people ages 15-64 of Middle East & North Africa (developing only) in 2006 to that in 2010?
Keep it short and to the point. 0.78. What is the ratio of the new registrations per 1,000 people ages 15-64 of Albania in 2006 to that in 2010?
Offer a very short reply. 0.69. What is the ratio of the new registrations per 1,000 people ages 15-64 of Croatia in 2006 to that in 2010?
Provide a succinct answer. 1.4. What is the ratio of the new registrations per 1,000 people ages 15-64 of Middle East & North Africa (developing only) in 2006 to that in 2011?
Offer a terse response. 0.79. What is the ratio of the new registrations per 1,000 people ages 15-64 of Albania in 2006 to that in 2011?
Keep it short and to the point. 0.79. What is the ratio of the new registrations per 1,000 people ages 15-64 in Croatia in 2006 to that in 2011?
Your answer should be very brief. 1.35. What is the ratio of the new registrations per 1,000 people ages 15-64 in Middle East & North Africa (developing only) in 2006 to that in 2012?
Ensure brevity in your answer.  0.84. What is the ratio of the new registrations per 1,000 people ages 15-64 of Albania in 2006 to that in 2012?
Your answer should be very brief. 0.78. What is the ratio of the new registrations per 1,000 people ages 15-64 of Croatia in 2006 to that in 2012?
Make the answer very short. 1.19. What is the ratio of the new registrations per 1,000 people ages 15-64 of Middle East & North Africa (developing only) in 2007 to that in 2008?
Keep it short and to the point. 0.95. What is the ratio of the new registrations per 1,000 people ages 15-64 in Albania in 2007 to that in 2008?
Ensure brevity in your answer.  0.73. What is the ratio of the new registrations per 1,000 people ages 15-64 in Croatia in 2007 to that in 2008?
Ensure brevity in your answer.  1.07. What is the ratio of the new registrations per 1,000 people ages 15-64 of Middle East & North Africa (developing only) in 2007 to that in 2009?
Ensure brevity in your answer.  0.93. What is the ratio of the new registrations per 1,000 people ages 15-64 in Albania in 2007 to that in 2009?
Ensure brevity in your answer.  1.07. What is the ratio of the new registrations per 1,000 people ages 15-64 in Croatia in 2007 to that in 2009?
Make the answer very short. 1.39. What is the ratio of the new registrations per 1,000 people ages 15-64 in Albania in 2007 to that in 2010?
Provide a short and direct response. 1.06. What is the ratio of the new registrations per 1,000 people ages 15-64 in Croatia in 2007 to that in 2010?
Make the answer very short. 1.5. What is the ratio of the new registrations per 1,000 people ages 15-64 in Middle East & North Africa (developing only) in 2007 to that in 2011?
Ensure brevity in your answer.  0.94. What is the ratio of the new registrations per 1,000 people ages 15-64 of Albania in 2007 to that in 2011?
Keep it short and to the point. 1.2. What is the ratio of the new registrations per 1,000 people ages 15-64 of Croatia in 2007 to that in 2011?
Your answer should be compact. 1.45. What is the ratio of the new registrations per 1,000 people ages 15-64 in Albania in 2007 to that in 2012?
Provide a short and direct response. 1.19. What is the ratio of the new registrations per 1,000 people ages 15-64 of Croatia in 2007 to that in 2012?
Offer a terse response. 1.28. What is the ratio of the new registrations per 1,000 people ages 15-64 of Middle East & North Africa (developing only) in 2008 to that in 2009?
Ensure brevity in your answer.  0.98. What is the ratio of the new registrations per 1,000 people ages 15-64 in Albania in 2008 to that in 2009?
Keep it short and to the point. 1.48. What is the ratio of the new registrations per 1,000 people ages 15-64 of Croatia in 2008 to that in 2009?
Your answer should be compact. 1.3. What is the ratio of the new registrations per 1,000 people ages 15-64 of Middle East & North Africa (developing only) in 2008 to that in 2010?
Ensure brevity in your answer.  0.98. What is the ratio of the new registrations per 1,000 people ages 15-64 of Albania in 2008 to that in 2010?
Provide a succinct answer. 1.46. What is the ratio of the new registrations per 1,000 people ages 15-64 of Croatia in 2008 to that in 2010?
Provide a short and direct response. 1.41. What is the ratio of the new registrations per 1,000 people ages 15-64 of Albania in 2008 to that in 2011?
Ensure brevity in your answer.  1.66. What is the ratio of the new registrations per 1,000 people ages 15-64 in Croatia in 2008 to that in 2011?
Provide a short and direct response. 1.36. What is the ratio of the new registrations per 1,000 people ages 15-64 of Middle East & North Africa (developing only) in 2008 to that in 2012?
Offer a terse response. 1.06. What is the ratio of the new registrations per 1,000 people ages 15-64 of Albania in 2008 to that in 2012?
Give a very brief answer. 1.64. What is the ratio of the new registrations per 1,000 people ages 15-64 in Croatia in 2008 to that in 2012?
Your response must be concise. 1.2. What is the ratio of the new registrations per 1,000 people ages 15-64 of Middle East & North Africa (developing only) in 2009 to that in 2010?
Provide a succinct answer. 1. What is the ratio of the new registrations per 1,000 people ages 15-64 of Albania in 2009 to that in 2010?
Offer a very short reply. 0.99. What is the ratio of the new registrations per 1,000 people ages 15-64 in Croatia in 2009 to that in 2010?
Provide a succinct answer. 1.08. What is the ratio of the new registrations per 1,000 people ages 15-64 in Middle East & North Africa (developing only) in 2009 to that in 2011?
Provide a short and direct response. 1.01. What is the ratio of the new registrations per 1,000 people ages 15-64 of Albania in 2009 to that in 2011?
Ensure brevity in your answer.  1.12. What is the ratio of the new registrations per 1,000 people ages 15-64 of Croatia in 2009 to that in 2011?
Give a very brief answer. 1.05. What is the ratio of the new registrations per 1,000 people ages 15-64 of Middle East & North Africa (developing only) in 2009 to that in 2012?
Ensure brevity in your answer.  1.08. What is the ratio of the new registrations per 1,000 people ages 15-64 in Albania in 2009 to that in 2012?
Provide a short and direct response. 1.11. What is the ratio of the new registrations per 1,000 people ages 15-64 in Croatia in 2009 to that in 2012?
Your answer should be very brief. 0.92. What is the ratio of the new registrations per 1,000 people ages 15-64 of Middle East & North Africa (developing only) in 2010 to that in 2011?
Ensure brevity in your answer.  1.01. What is the ratio of the new registrations per 1,000 people ages 15-64 in Albania in 2010 to that in 2011?
Your answer should be compact. 1.14. What is the ratio of the new registrations per 1,000 people ages 15-64 of Croatia in 2010 to that in 2011?
Offer a very short reply. 0.97. What is the ratio of the new registrations per 1,000 people ages 15-64 of Middle East & North Africa (developing only) in 2010 to that in 2012?
Offer a very short reply. 1.08. What is the ratio of the new registrations per 1,000 people ages 15-64 of Albania in 2010 to that in 2012?
Provide a succinct answer. 1.13. What is the ratio of the new registrations per 1,000 people ages 15-64 of Croatia in 2010 to that in 2012?
Your response must be concise. 0.85. What is the ratio of the new registrations per 1,000 people ages 15-64 in Middle East & North Africa (developing only) in 2011 to that in 2012?
Your answer should be very brief. 1.07. What is the ratio of the new registrations per 1,000 people ages 15-64 in Albania in 2011 to that in 2012?
Keep it short and to the point. 0.99. What is the ratio of the new registrations per 1,000 people ages 15-64 of Croatia in 2011 to that in 2012?
Offer a terse response. 0.88. What is the difference between the highest and the second highest new registrations per 1,000 people ages 15-64 in Middle East & North Africa (developing only)?
Your answer should be very brief. 0. What is the difference between the highest and the second highest new registrations per 1,000 people ages 15-64 in Albania?
Give a very brief answer. 0.39. What is the difference between the highest and the second highest new registrations per 1,000 people ages 15-64 in Croatia?
Keep it short and to the point. 0.22. What is the difference between the highest and the lowest new registrations per 1,000 people ages 15-64 in Middle East & North Africa (developing only)?
Your answer should be compact. 0.16. What is the difference between the highest and the lowest new registrations per 1,000 people ages 15-64 of Albania?
Your response must be concise. 0.84. What is the difference between the highest and the lowest new registrations per 1,000 people ages 15-64 of Croatia?
Provide a succinct answer. 1.2. 